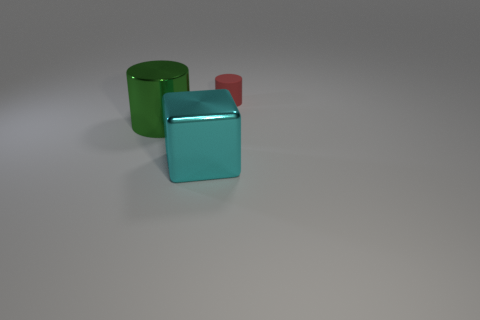How many matte things are cyan cubes or large spheres?
Make the answer very short. 0. Is there anything else that has the same material as the red cylinder?
Ensure brevity in your answer.  No. What number of objects are either big metallic cylinders or things behind the large green metal object?
Provide a succinct answer. 2. Do the object that is to the left of the cyan object and the large block have the same size?
Offer a terse response. Yes. How many other objects are there of the same shape as the large green thing?
Offer a very short reply. 1. How many yellow things are tiny rubber objects or big blocks?
Give a very brief answer. 0. There is a green thing that is made of the same material as the cyan object; what is its shape?
Offer a very short reply. Cylinder. What color is the thing that is on the right side of the green thing and behind the large cyan shiny block?
Ensure brevity in your answer.  Red. There is a cylinder behind the thing that is left of the big cyan block; how big is it?
Offer a terse response. Small. Are there an equal number of tiny red things that are in front of the tiny matte cylinder and blue rubber cubes?
Ensure brevity in your answer.  Yes. 